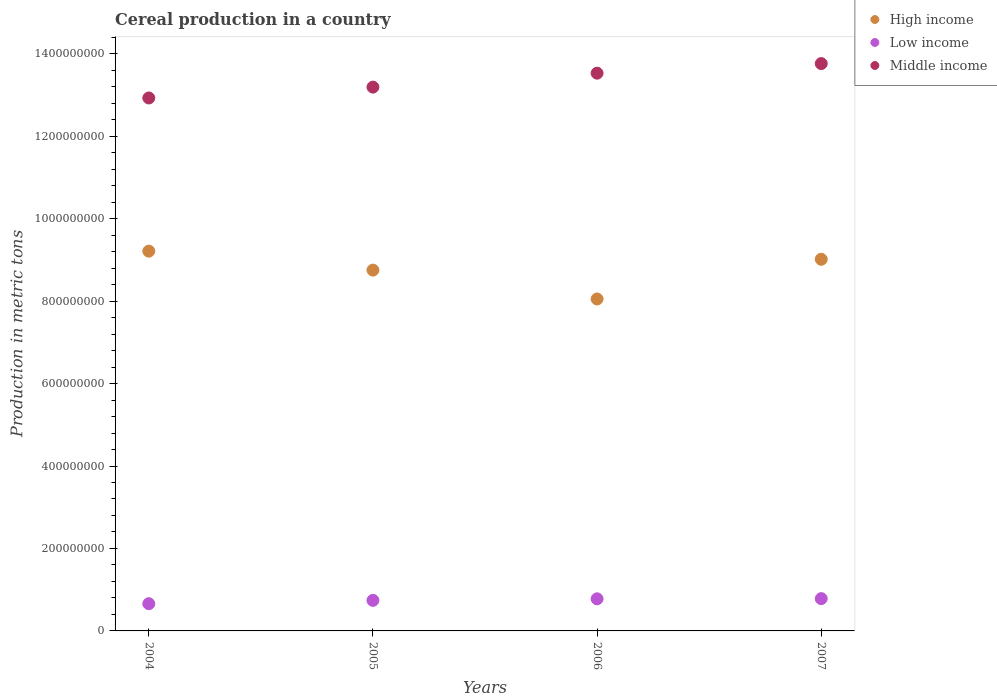How many different coloured dotlines are there?
Keep it short and to the point. 3. Is the number of dotlines equal to the number of legend labels?
Your response must be concise. Yes. What is the total cereal production in Low income in 2006?
Offer a very short reply. 7.78e+07. Across all years, what is the maximum total cereal production in High income?
Ensure brevity in your answer.  9.21e+08. Across all years, what is the minimum total cereal production in High income?
Offer a very short reply. 8.05e+08. In which year was the total cereal production in High income minimum?
Provide a succinct answer. 2006. What is the total total cereal production in High income in the graph?
Offer a terse response. 3.50e+09. What is the difference between the total cereal production in Middle income in 2004 and that in 2005?
Your answer should be compact. -2.63e+07. What is the difference between the total cereal production in Middle income in 2006 and the total cereal production in Low income in 2004?
Your answer should be very brief. 1.29e+09. What is the average total cereal production in High income per year?
Offer a terse response. 8.76e+08. In the year 2004, what is the difference between the total cereal production in Middle income and total cereal production in High income?
Give a very brief answer. 3.72e+08. What is the ratio of the total cereal production in Middle income in 2006 to that in 2007?
Offer a terse response. 0.98. What is the difference between the highest and the second highest total cereal production in Middle income?
Ensure brevity in your answer.  2.32e+07. What is the difference between the highest and the lowest total cereal production in High income?
Your response must be concise. 1.16e+08. Is the total cereal production in High income strictly greater than the total cereal production in Low income over the years?
Your answer should be compact. Yes. Is the total cereal production in High income strictly less than the total cereal production in Low income over the years?
Make the answer very short. No. How many dotlines are there?
Provide a short and direct response. 3. How many legend labels are there?
Make the answer very short. 3. How are the legend labels stacked?
Ensure brevity in your answer.  Vertical. What is the title of the graph?
Make the answer very short. Cereal production in a country. Does "Vanuatu" appear as one of the legend labels in the graph?
Offer a terse response. No. What is the label or title of the X-axis?
Keep it short and to the point. Years. What is the label or title of the Y-axis?
Your answer should be compact. Production in metric tons. What is the Production in metric tons of High income in 2004?
Your answer should be compact. 9.21e+08. What is the Production in metric tons in Low income in 2004?
Provide a succinct answer. 6.61e+07. What is the Production in metric tons of Middle income in 2004?
Make the answer very short. 1.29e+09. What is the Production in metric tons in High income in 2005?
Your answer should be compact. 8.75e+08. What is the Production in metric tons in Low income in 2005?
Keep it short and to the point. 7.41e+07. What is the Production in metric tons of Middle income in 2005?
Offer a terse response. 1.32e+09. What is the Production in metric tons in High income in 2006?
Your response must be concise. 8.05e+08. What is the Production in metric tons of Low income in 2006?
Your answer should be compact. 7.78e+07. What is the Production in metric tons of Middle income in 2006?
Provide a succinct answer. 1.35e+09. What is the Production in metric tons in High income in 2007?
Provide a short and direct response. 9.01e+08. What is the Production in metric tons in Low income in 2007?
Your response must be concise. 7.83e+07. What is the Production in metric tons in Middle income in 2007?
Make the answer very short. 1.38e+09. Across all years, what is the maximum Production in metric tons in High income?
Offer a very short reply. 9.21e+08. Across all years, what is the maximum Production in metric tons in Low income?
Provide a succinct answer. 7.83e+07. Across all years, what is the maximum Production in metric tons of Middle income?
Keep it short and to the point. 1.38e+09. Across all years, what is the minimum Production in metric tons of High income?
Make the answer very short. 8.05e+08. Across all years, what is the minimum Production in metric tons in Low income?
Give a very brief answer. 6.61e+07. Across all years, what is the minimum Production in metric tons of Middle income?
Ensure brevity in your answer.  1.29e+09. What is the total Production in metric tons of High income in the graph?
Give a very brief answer. 3.50e+09. What is the total Production in metric tons of Low income in the graph?
Keep it short and to the point. 2.96e+08. What is the total Production in metric tons of Middle income in the graph?
Give a very brief answer. 5.34e+09. What is the difference between the Production in metric tons in High income in 2004 and that in 2005?
Provide a succinct answer. 4.60e+07. What is the difference between the Production in metric tons in Low income in 2004 and that in 2005?
Your answer should be very brief. -8.03e+06. What is the difference between the Production in metric tons in Middle income in 2004 and that in 2005?
Your answer should be compact. -2.63e+07. What is the difference between the Production in metric tons in High income in 2004 and that in 2006?
Your response must be concise. 1.16e+08. What is the difference between the Production in metric tons in Low income in 2004 and that in 2006?
Make the answer very short. -1.18e+07. What is the difference between the Production in metric tons of Middle income in 2004 and that in 2006?
Make the answer very short. -6.02e+07. What is the difference between the Production in metric tons of High income in 2004 and that in 2007?
Your response must be concise. 1.97e+07. What is the difference between the Production in metric tons in Low income in 2004 and that in 2007?
Your answer should be very brief. -1.23e+07. What is the difference between the Production in metric tons in Middle income in 2004 and that in 2007?
Keep it short and to the point. -8.34e+07. What is the difference between the Production in metric tons of High income in 2005 and that in 2006?
Provide a succinct answer. 7.00e+07. What is the difference between the Production in metric tons of Low income in 2005 and that in 2006?
Keep it short and to the point. -3.76e+06. What is the difference between the Production in metric tons of Middle income in 2005 and that in 2006?
Your response must be concise. -3.39e+07. What is the difference between the Production in metric tons in High income in 2005 and that in 2007?
Your answer should be compact. -2.63e+07. What is the difference between the Production in metric tons of Low income in 2005 and that in 2007?
Give a very brief answer. -4.24e+06. What is the difference between the Production in metric tons in Middle income in 2005 and that in 2007?
Give a very brief answer. -5.71e+07. What is the difference between the Production in metric tons of High income in 2006 and that in 2007?
Offer a terse response. -9.63e+07. What is the difference between the Production in metric tons in Low income in 2006 and that in 2007?
Make the answer very short. -4.81e+05. What is the difference between the Production in metric tons in Middle income in 2006 and that in 2007?
Offer a very short reply. -2.32e+07. What is the difference between the Production in metric tons of High income in 2004 and the Production in metric tons of Low income in 2005?
Make the answer very short. 8.47e+08. What is the difference between the Production in metric tons in High income in 2004 and the Production in metric tons in Middle income in 2005?
Offer a very short reply. -3.98e+08. What is the difference between the Production in metric tons in Low income in 2004 and the Production in metric tons in Middle income in 2005?
Your answer should be compact. -1.25e+09. What is the difference between the Production in metric tons in High income in 2004 and the Production in metric tons in Low income in 2006?
Provide a short and direct response. 8.43e+08. What is the difference between the Production in metric tons in High income in 2004 and the Production in metric tons in Middle income in 2006?
Your answer should be very brief. -4.32e+08. What is the difference between the Production in metric tons in Low income in 2004 and the Production in metric tons in Middle income in 2006?
Make the answer very short. -1.29e+09. What is the difference between the Production in metric tons of High income in 2004 and the Production in metric tons of Low income in 2007?
Offer a terse response. 8.43e+08. What is the difference between the Production in metric tons in High income in 2004 and the Production in metric tons in Middle income in 2007?
Provide a succinct answer. -4.55e+08. What is the difference between the Production in metric tons of Low income in 2004 and the Production in metric tons of Middle income in 2007?
Provide a succinct answer. -1.31e+09. What is the difference between the Production in metric tons in High income in 2005 and the Production in metric tons in Low income in 2006?
Your answer should be very brief. 7.97e+08. What is the difference between the Production in metric tons in High income in 2005 and the Production in metric tons in Middle income in 2006?
Provide a short and direct response. -4.78e+08. What is the difference between the Production in metric tons of Low income in 2005 and the Production in metric tons of Middle income in 2006?
Your answer should be very brief. -1.28e+09. What is the difference between the Production in metric tons of High income in 2005 and the Production in metric tons of Low income in 2007?
Offer a very short reply. 7.97e+08. What is the difference between the Production in metric tons in High income in 2005 and the Production in metric tons in Middle income in 2007?
Make the answer very short. -5.01e+08. What is the difference between the Production in metric tons of Low income in 2005 and the Production in metric tons of Middle income in 2007?
Provide a succinct answer. -1.30e+09. What is the difference between the Production in metric tons in High income in 2006 and the Production in metric tons in Low income in 2007?
Offer a very short reply. 7.27e+08. What is the difference between the Production in metric tons of High income in 2006 and the Production in metric tons of Middle income in 2007?
Offer a terse response. -5.71e+08. What is the difference between the Production in metric tons in Low income in 2006 and the Production in metric tons in Middle income in 2007?
Offer a very short reply. -1.30e+09. What is the average Production in metric tons of High income per year?
Your answer should be compact. 8.76e+08. What is the average Production in metric tons in Low income per year?
Your answer should be compact. 7.41e+07. What is the average Production in metric tons in Middle income per year?
Provide a succinct answer. 1.34e+09. In the year 2004, what is the difference between the Production in metric tons of High income and Production in metric tons of Low income?
Ensure brevity in your answer.  8.55e+08. In the year 2004, what is the difference between the Production in metric tons in High income and Production in metric tons in Middle income?
Ensure brevity in your answer.  -3.72e+08. In the year 2004, what is the difference between the Production in metric tons in Low income and Production in metric tons in Middle income?
Offer a terse response. -1.23e+09. In the year 2005, what is the difference between the Production in metric tons of High income and Production in metric tons of Low income?
Keep it short and to the point. 8.01e+08. In the year 2005, what is the difference between the Production in metric tons in High income and Production in metric tons in Middle income?
Provide a short and direct response. -4.44e+08. In the year 2005, what is the difference between the Production in metric tons of Low income and Production in metric tons of Middle income?
Keep it short and to the point. -1.24e+09. In the year 2006, what is the difference between the Production in metric tons of High income and Production in metric tons of Low income?
Provide a short and direct response. 7.27e+08. In the year 2006, what is the difference between the Production in metric tons in High income and Production in metric tons in Middle income?
Your answer should be very brief. -5.48e+08. In the year 2006, what is the difference between the Production in metric tons of Low income and Production in metric tons of Middle income?
Offer a very short reply. -1.27e+09. In the year 2007, what is the difference between the Production in metric tons in High income and Production in metric tons in Low income?
Keep it short and to the point. 8.23e+08. In the year 2007, what is the difference between the Production in metric tons of High income and Production in metric tons of Middle income?
Your answer should be very brief. -4.75e+08. In the year 2007, what is the difference between the Production in metric tons in Low income and Production in metric tons in Middle income?
Provide a succinct answer. -1.30e+09. What is the ratio of the Production in metric tons of High income in 2004 to that in 2005?
Provide a succinct answer. 1.05. What is the ratio of the Production in metric tons in Low income in 2004 to that in 2005?
Keep it short and to the point. 0.89. What is the ratio of the Production in metric tons of High income in 2004 to that in 2006?
Provide a succinct answer. 1.14. What is the ratio of the Production in metric tons of Low income in 2004 to that in 2006?
Offer a very short reply. 0.85. What is the ratio of the Production in metric tons in Middle income in 2004 to that in 2006?
Your answer should be compact. 0.96. What is the ratio of the Production in metric tons in High income in 2004 to that in 2007?
Provide a short and direct response. 1.02. What is the ratio of the Production in metric tons in Low income in 2004 to that in 2007?
Offer a terse response. 0.84. What is the ratio of the Production in metric tons in Middle income in 2004 to that in 2007?
Your answer should be very brief. 0.94. What is the ratio of the Production in metric tons in High income in 2005 to that in 2006?
Ensure brevity in your answer.  1.09. What is the ratio of the Production in metric tons in Low income in 2005 to that in 2006?
Provide a succinct answer. 0.95. What is the ratio of the Production in metric tons in Middle income in 2005 to that in 2006?
Your answer should be very brief. 0.97. What is the ratio of the Production in metric tons in High income in 2005 to that in 2007?
Give a very brief answer. 0.97. What is the ratio of the Production in metric tons of Low income in 2005 to that in 2007?
Keep it short and to the point. 0.95. What is the ratio of the Production in metric tons of Middle income in 2005 to that in 2007?
Your answer should be compact. 0.96. What is the ratio of the Production in metric tons in High income in 2006 to that in 2007?
Make the answer very short. 0.89. What is the ratio of the Production in metric tons in Middle income in 2006 to that in 2007?
Ensure brevity in your answer.  0.98. What is the difference between the highest and the second highest Production in metric tons in High income?
Your answer should be very brief. 1.97e+07. What is the difference between the highest and the second highest Production in metric tons in Low income?
Offer a very short reply. 4.81e+05. What is the difference between the highest and the second highest Production in metric tons in Middle income?
Give a very brief answer. 2.32e+07. What is the difference between the highest and the lowest Production in metric tons of High income?
Make the answer very short. 1.16e+08. What is the difference between the highest and the lowest Production in metric tons in Low income?
Offer a terse response. 1.23e+07. What is the difference between the highest and the lowest Production in metric tons in Middle income?
Your response must be concise. 8.34e+07. 